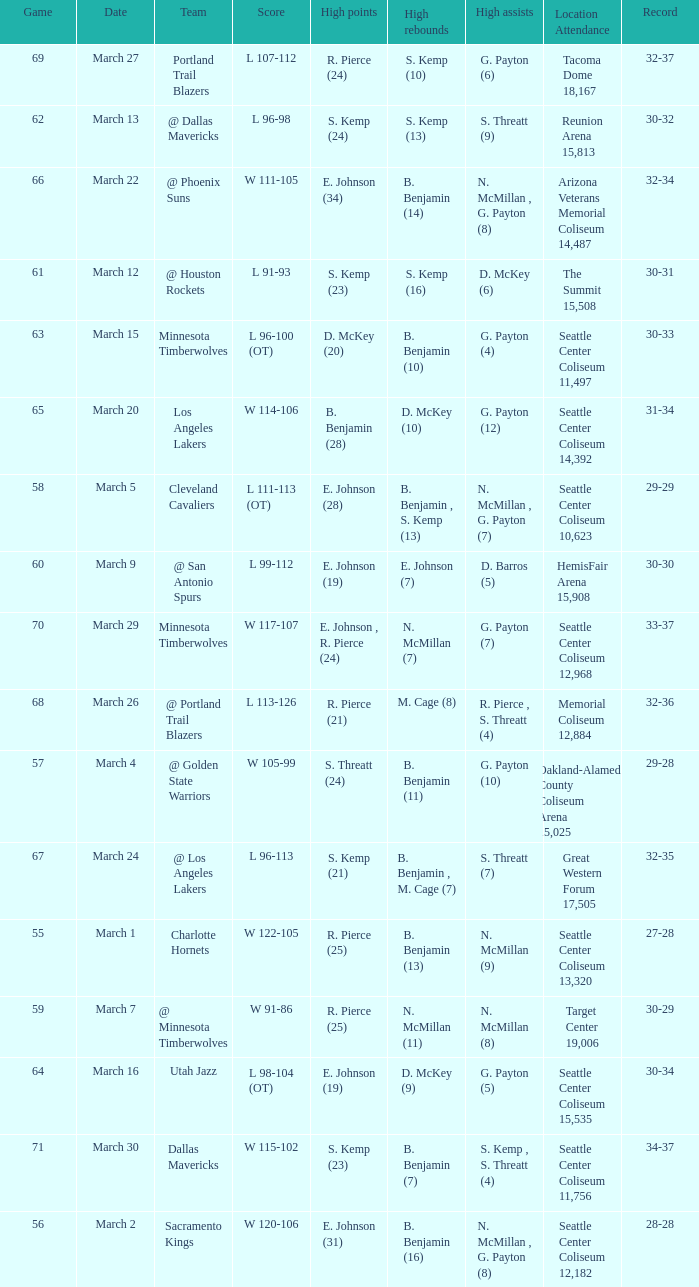Which game was played on march 2? 56.0. 